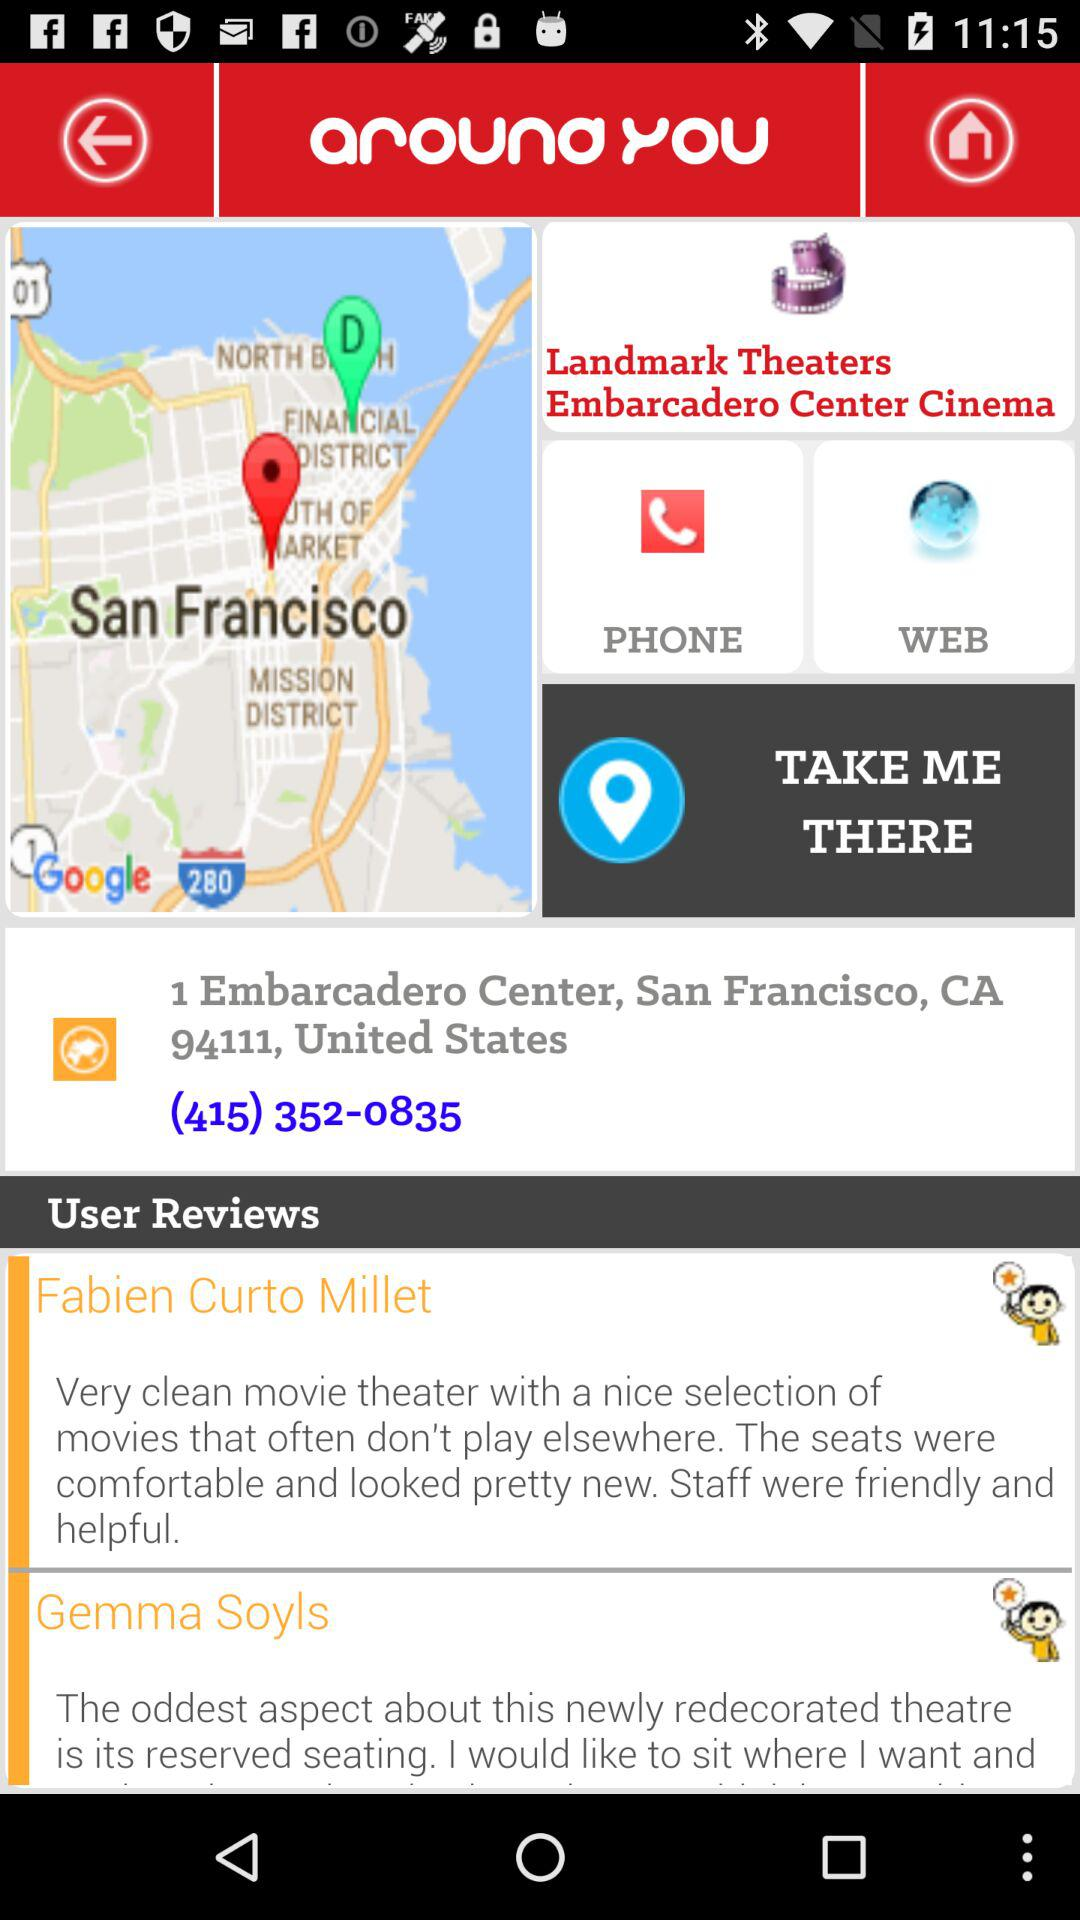What is the shown address? The shown address is 1 Embarcadero Center, San Francisco, CA 94111, United States. 